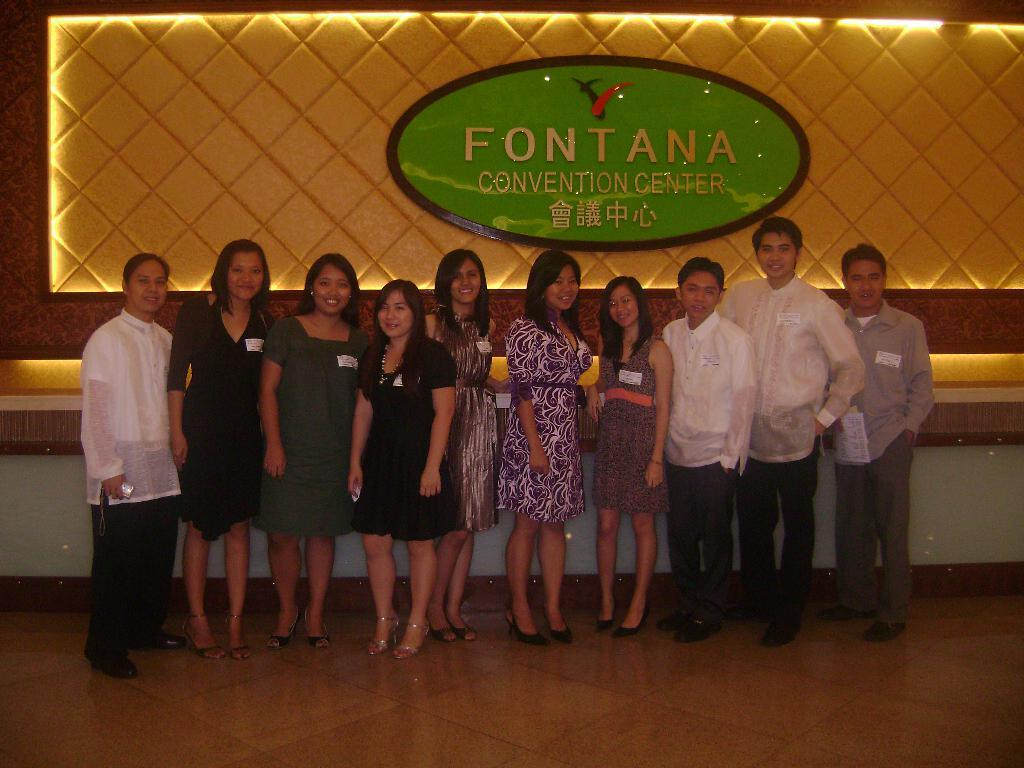How many people are in the image? There is a group of people standing in the image, but the exact number cannot be determined from the provided facts. What can be seen in the background of the image? There is a board and a wall in the background of the image. What type of vegetable is being used as a prop by one of the people in the image? There is no vegetable present in the image, and therefore no such prop can be observed. 